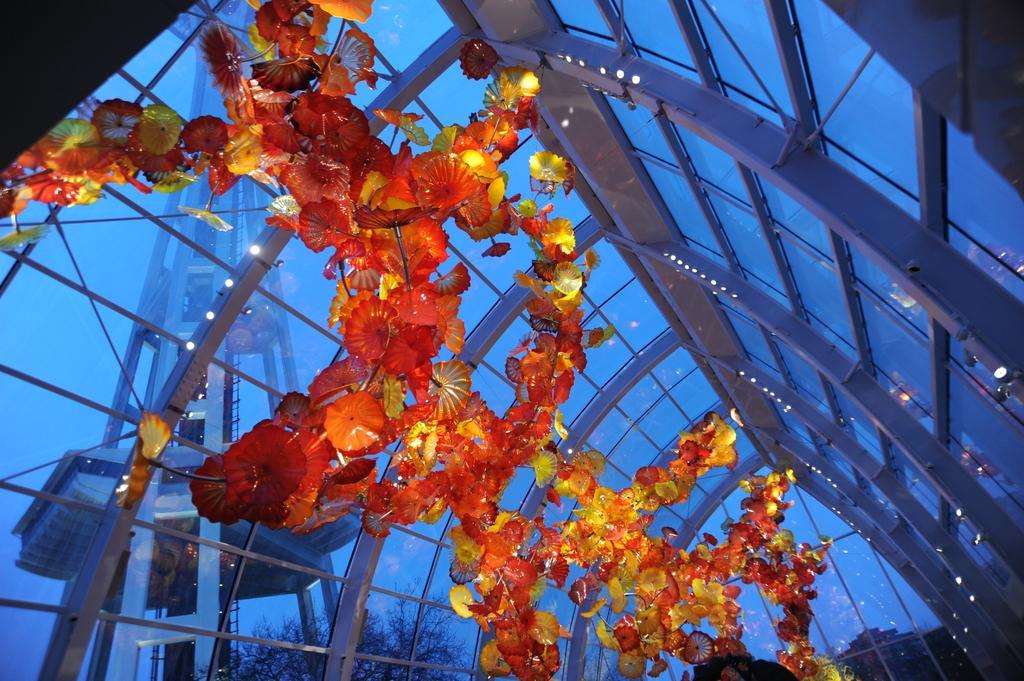Can you describe this image briefly? In this image, these look like the artificial flowers, which are used for decorating. This is the roof with the glass doors. I can see the tower. At the bottom of the image, these look like the trees. 